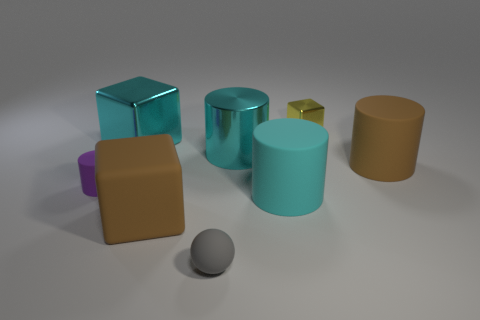Add 1 brown rubber objects. How many objects exist? 9 Subtract all blocks. How many objects are left? 5 Subtract 0 green balls. How many objects are left? 8 Subtract all tiny brown cubes. Subtract all big brown matte cubes. How many objects are left? 7 Add 5 small purple matte things. How many small purple matte things are left? 6 Add 1 cyan metallic objects. How many cyan metallic objects exist? 3 